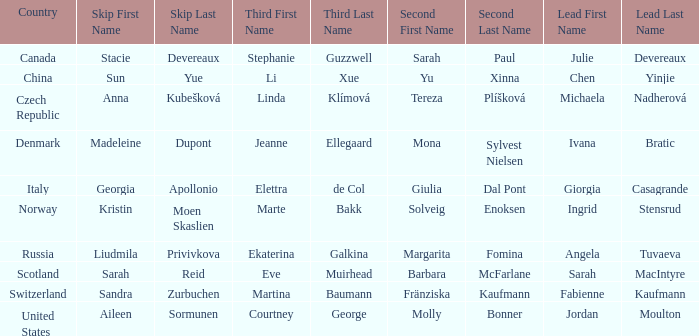What skip has norway as the country? Kristin Moen Skaslien. 